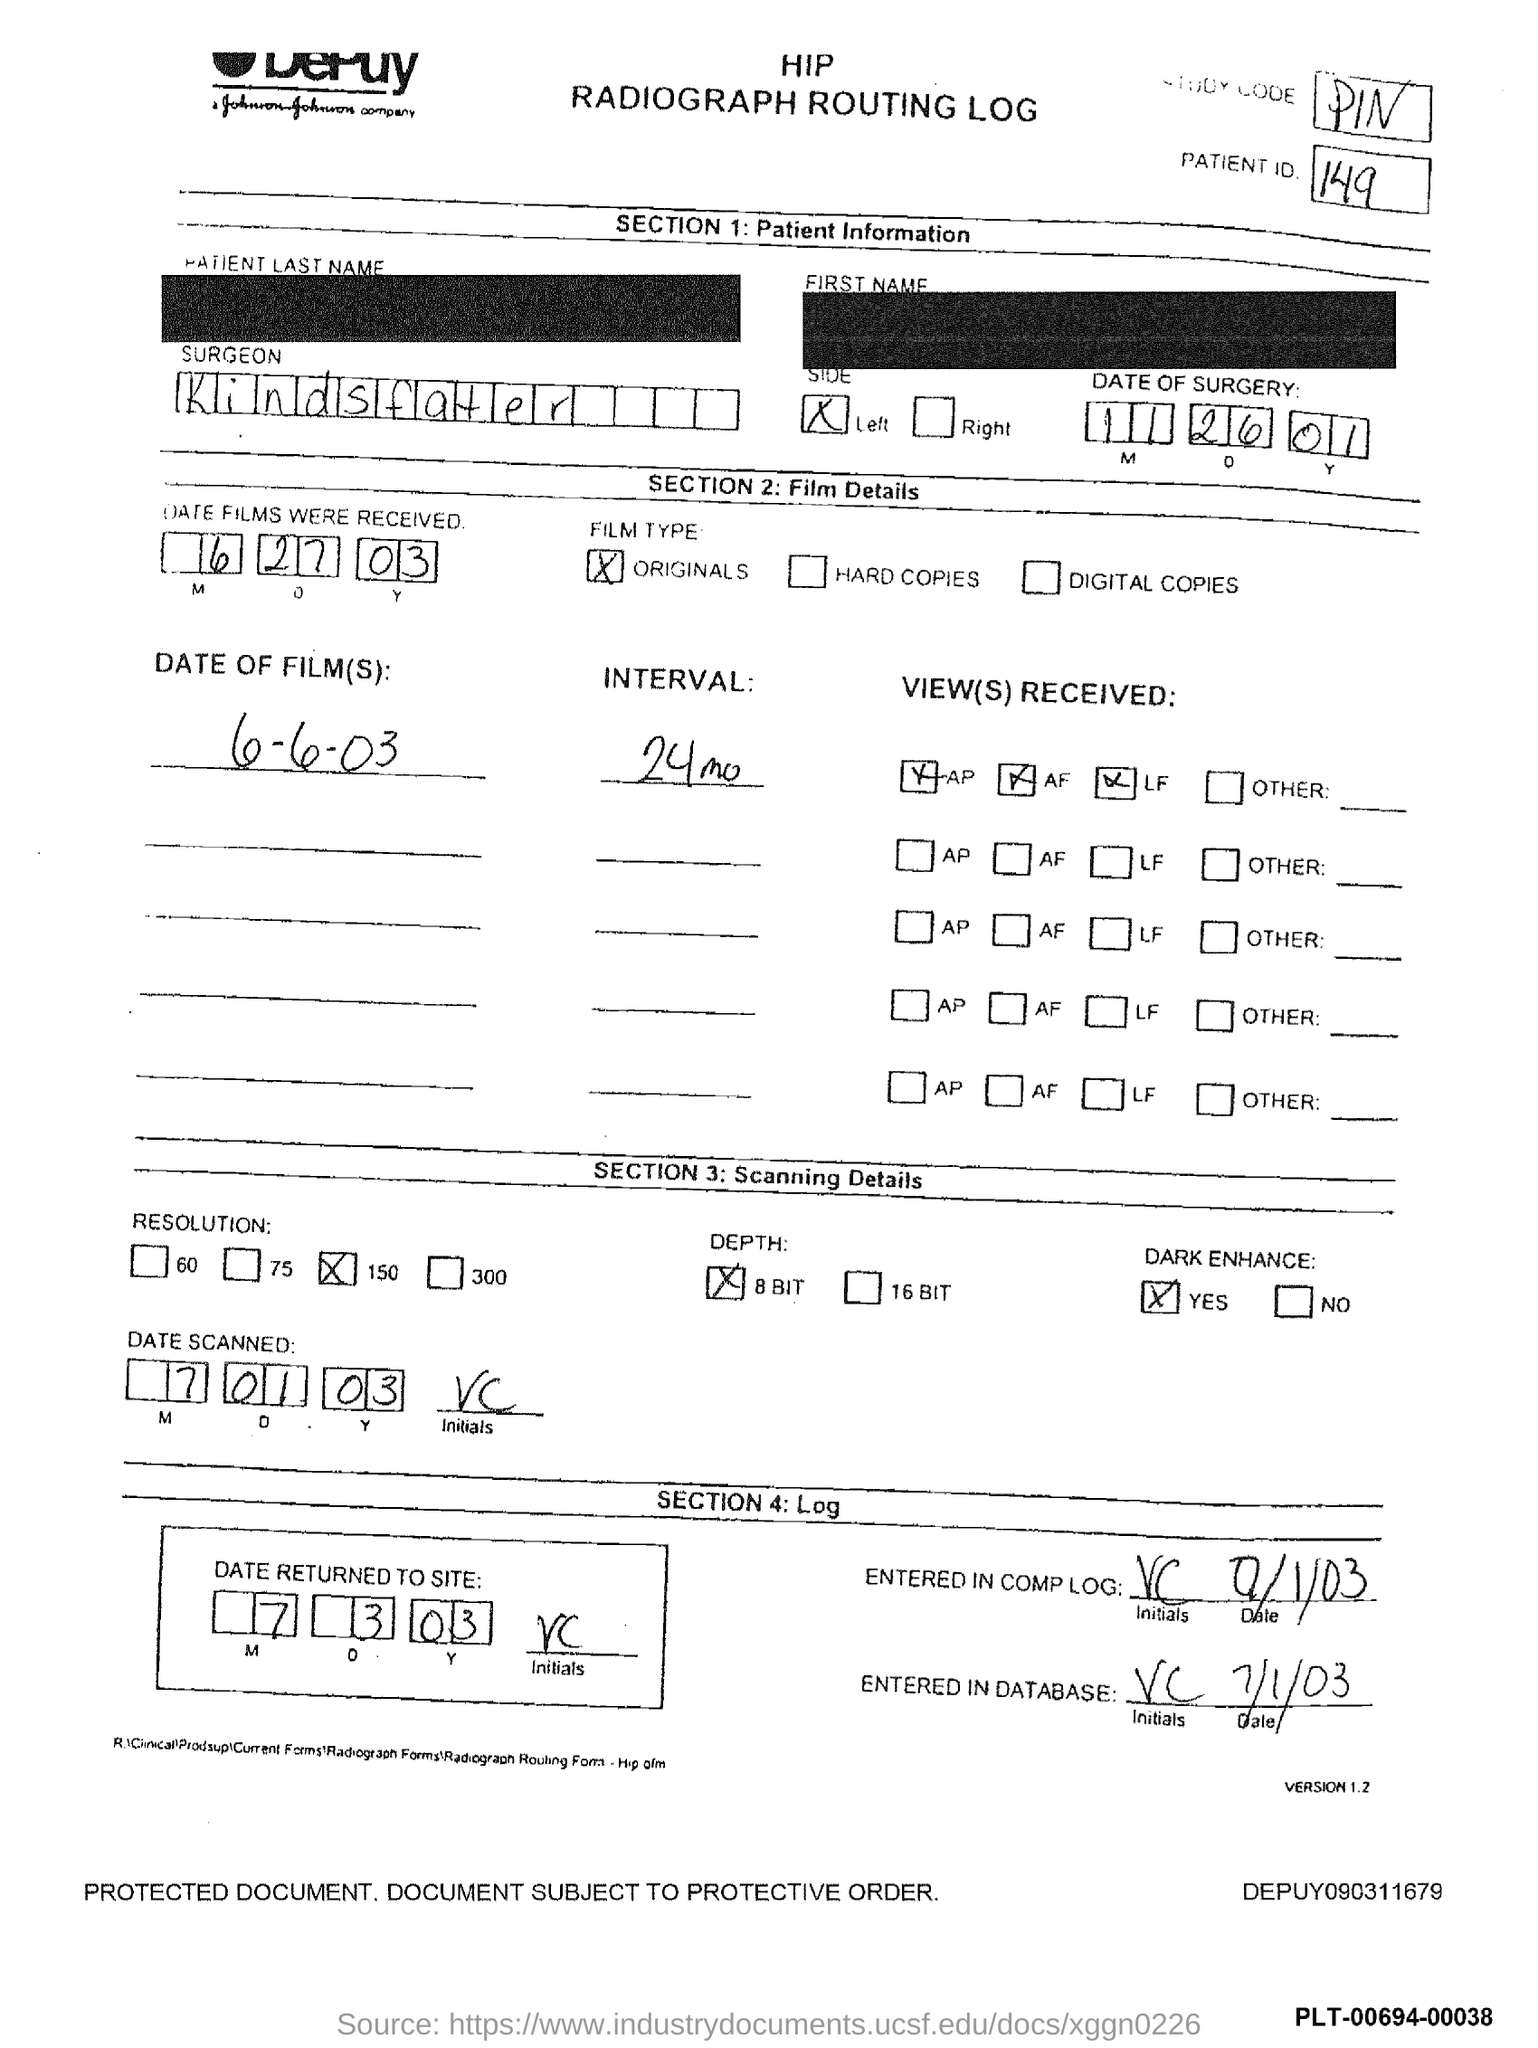What is the Patient id?
Provide a short and direct response. 149. What is the name of the Surgeon?
Your answer should be compact. Kindsfater. 